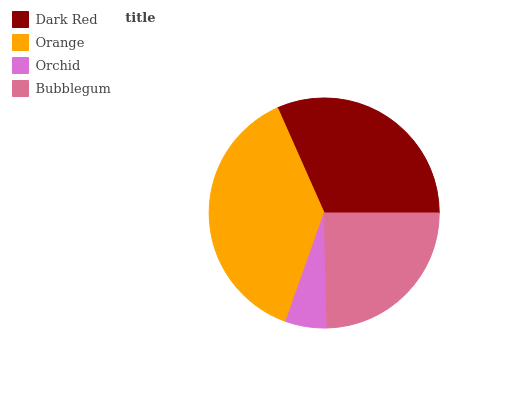Is Orchid the minimum?
Answer yes or no. Yes. Is Orange the maximum?
Answer yes or no. Yes. Is Orange the minimum?
Answer yes or no. No. Is Orchid the maximum?
Answer yes or no. No. Is Orange greater than Orchid?
Answer yes or no. Yes. Is Orchid less than Orange?
Answer yes or no. Yes. Is Orchid greater than Orange?
Answer yes or no. No. Is Orange less than Orchid?
Answer yes or no. No. Is Dark Red the high median?
Answer yes or no. Yes. Is Bubblegum the low median?
Answer yes or no. Yes. Is Orange the high median?
Answer yes or no. No. Is Orchid the low median?
Answer yes or no. No. 